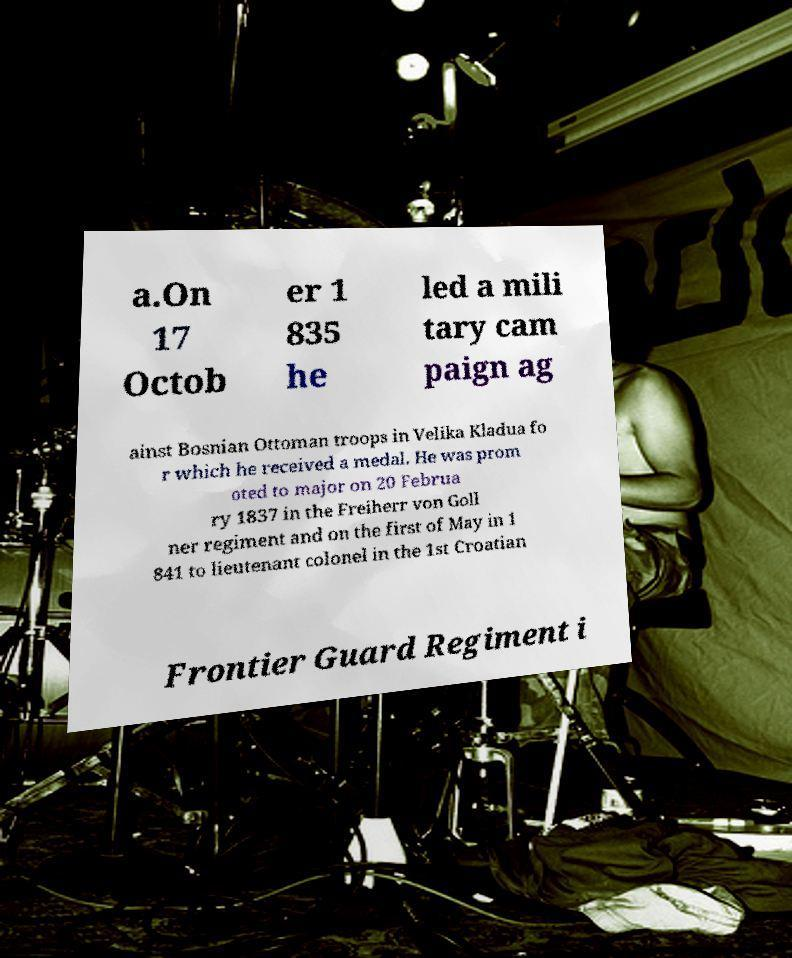Please identify and transcribe the text found in this image. a.On 17 Octob er 1 835 he led a mili tary cam paign ag ainst Bosnian Ottoman troops in Velika Kladua fo r which he received a medal. He was prom oted to major on 20 Februa ry 1837 in the Freiherr von Goll ner regiment and on the first of May in 1 841 to lieutenant colonel in the 1st Croatian Frontier Guard Regiment i 